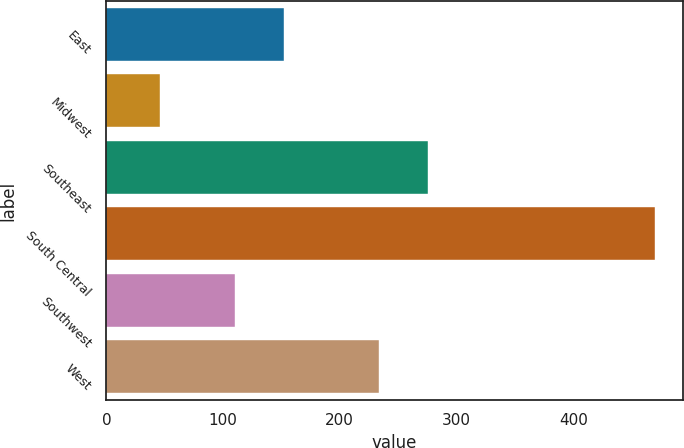<chart> <loc_0><loc_0><loc_500><loc_500><bar_chart><fcel>East<fcel>Midwest<fcel>Southeast<fcel>South Central<fcel>Southwest<fcel>West<nl><fcel>152.34<fcel>45.9<fcel>275.94<fcel>470.3<fcel>109.9<fcel>233.5<nl></chart> 